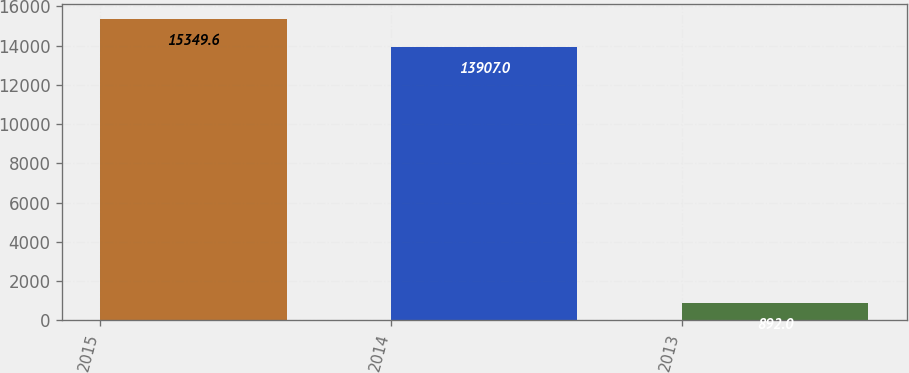<chart> <loc_0><loc_0><loc_500><loc_500><bar_chart><fcel>2015<fcel>2014<fcel>2013<nl><fcel>15349.6<fcel>13907<fcel>892<nl></chart> 